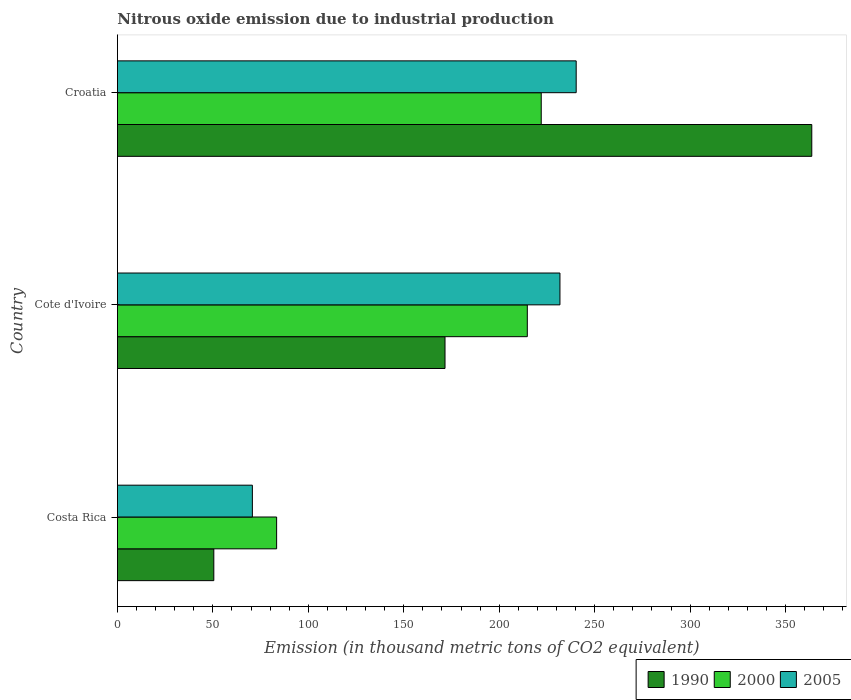How many different coloured bars are there?
Your response must be concise. 3. How many groups of bars are there?
Offer a very short reply. 3. Are the number of bars per tick equal to the number of legend labels?
Provide a short and direct response. Yes. Are the number of bars on each tick of the Y-axis equal?
Offer a terse response. Yes. How many bars are there on the 1st tick from the top?
Provide a short and direct response. 3. What is the label of the 2nd group of bars from the top?
Your response must be concise. Cote d'Ivoire. In how many cases, is the number of bars for a given country not equal to the number of legend labels?
Offer a very short reply. 0. What is the amount of nitrous oxide emitted in 2000 in Croatia?
Give a very brief answer. 222. Across all countries, what is the maximum amount of nitrous oxide emitted in 2000?
Give a very brief answer. 222. Across all countries, what is the minimum amount of nitrous oxide emitted in 2000?
Your answer should be compact. 83.4. In which country was the amount of nitrous oxide emitted in 2005 maximum?
Your response must be concise. Croatia. In which country was the amount of nitrous oxide emitted in 2000 minimum?
Offer a terse response. Costa Rica. What is the total amount of nitrous oxide emitted in 2000 in the graph?
Offer a very short reply. 520.1. What is the difference between the amount of nitrous oxide emitted in 1990 in Costa Rica and that in Croatia?
Give a very brief answer. -313.2. What is the difference between the amount of nitrous oxide emitted in 1990 in Cote d'Ivoire and the amount of nitrous oxide emitted in 2000 in Costa Rica?
Your answer should be compact. 88.2. What is the average amount of nitrous oxide emitted in 2005 per country?
Offer a very short reply. 180.93. What is the difference between the amount of nitrous oxide emitted in 2005 and amount of nitrous oxide emitted in 1990 in Costa Rica?
Your response must be concise. 20.2. In how many countries, is the amount of nitrous oxide emitted in 1990 greater than 330 thousand metric tons?
Give a very brief answer. 1. What is the ratio of the amount of nitrous oxide emitted in 2005 in Costa Rica to that in Croatia?
Ensure brevity in your answer.  0.29. Is the amount of nitrous oxide emitted in 1990 in Costa Rica less than that in Croatia?
Offer a very short reply. Yes. Is the difference between the amount of nitrous oxide emitted in 2005 in Costa Rica and Croatia greater than the difference between the amount of nitrous oxide emitted in 1990 in Costa Rica and Croatia?
Your response must be concise. Yes. What is the difference between the highest and the lowest amount of nitrous oxide emitted in 1990?
Your answer should be compact. 313.2. Is the sum of the amount of nitrous oxide emitted in 2000 in Cote d'Ivoire and Croatia greater than the maximum amount of nitrous oxide emitted in 1990 across all countries?
Your response must be concise. Yes. What does the 3rd bar from the top in Croatia represents?
Your answer should be very brief. 1990. Are all the bars in the graph horizontal?
Provide a short and direct response. Yes. How many countries are there in the graph?
Keep it short and to the point. 3. Are the values on the major ticks of X-axis written in scientific E-notation?
Provide a short and direct response. No. Does the graph contain any zero values?
Keep it short and to the point. No. What is the title of the graph?
Make the answer very short. Nitrous oxide emission due to industrial production. What is the label or title of the X-axis?
Provide a short and direct response. Emission (in thousand metric tons of CO2 equivalent). What is the label or title of the Y-axis?
Make the answer very short. Country. What is the Emission (in thousand metric tons of CO2 equivalent) of 1990 in Costa Rica?
Make the answer very short. 50.5. What is the Emission (in thousand metric tons of CO2 equivalent) of 2000 in Costa Rica?
Offer a terse response. 83.4. What is the Emission (in thousand metric tons of CO2 equivalent) of 2005 in Costa Rica?
Offer a terse response. 70.7. What is the Emission (in thousand metric tons of CO2 equivalent) of 1990 in Cote d'Ivoire?
Provide a short and direct response. 171.6. What is the Emission (in thousand metric tons of CO2 equivalent) in 2000 in Cote d'Ivoire?
Make the answer very short. 214.7. What is the Emission (in thousand metric tons of CO2 equivalent) in 2005 in Cote d'Ivoire?
Ensure brevity in your answer.  231.8. What is the Emission (in thousand metric tons of CO2 equivalent) in 1990 in Croatia?
Offer a very short reply. 363.7. What is the Emission (in thousand metric tons of CO2 equivalent) of 2000 in Croatia?
Your answer should be very brief. 222. What is the Emission (in thousand metric tons of CO2 equivalent) of 2005 in Croatia?
Your answer should be compact. 240.3. Across all countries, what is the maximum Emission (in thousand metric tons of CO2 equivalent) of 1990?
Keep it short and to the point. 363.7. Across all countries, what is the maximum Emission (in thousand metric tons of CO2 equivalent) in 2000?
Offer a very short reply. 222. Across all countries, what is the maximum Emission (in thousand metric tons of CO2 equivalent) of 2005?
Your answer should be very brief. 240.3. Across all countries, what is the minimum Emission (in thousand metric tons of CO2 equivalent) of 1990?
Make the answer very short. 50.5. Across all countries, what is the minimum Emission (in thousand metric tons of CO2 equivalent) in 2000?
Provide a short and direct response. 83.4. Across all countries, what is the minimum Emission (in thousand metric tons of CO2 equivalent) in 2005?
Provide a short and direct response. 70.7. What is the total Emission (in thousand metric tons of CO2 equivalent) in 1990 in the graph?
Your answer should be very brief. 585.8. What is the total Emission (in thousand metric tons of CO2 equivalent) in 2000 in the graph?
Keep it short and to the point. 520.1. What is the total Emission (in thousand metric tons of CO2 equivalent) in 2005 in the graph?
Your answer should be very brief. 542.8. What is the difference between the Emission (in thousand metric tons of CO2 equivalent) in 1990 in Costa Rica and that in Cote d'Ivoire?
Your response must be concise. -121.1. What is the difference between the Emission (in thousand metric tons of CO2 equivalent) of 2000 in Costa Rica and that in Cote d'Ivoire?
Your answer should be very brief. -131.3. What is the difference between the Emission (in thousand metric tons of CO2 equivalent) of 2005 in Costa Rica and that in Cote d'Ivoire?
Offer a terse response. -161.1. What is the difference between the Emission (in thousand metric tons of CO2 equivalent) in 1990 in Costa Rica and that in Croatia?
Offer a very short reply. -313.2. What is the difference between the Emission (in thousand metric tons of CO2 equivalent) of 2000 in Costa Rica and that in Croatia?
Provide a short and direct response. -138.6. What is the difference between the Emission (in thousand metric tons of CO2 equivalent) in 2005 in Costa Rica and that in Croatia?
Offer a very short reply. -169.6. What is the difference between the Emission (in thousand metric tons of CO2 equivalent) of 1990 in Cote d'Ivoire and that in Croatia?
Make the answer very short. -192.1. What is the difference between the Emission (in thousand metric tons of CO2 equivalent) in 1990 in Costa Rica and the Emission (in thousand metric tons of CO2 equivalent) in 2000 in Cote d'Ivoire?
Your response must be concise. -164.2. What is the difference between the Emission (in thousand metric tons of CO2 equivalent) in 1990 in Costa Rica and the Emission (in thousand metric tons of CO2 equivalent) in 2005 in Cote d'Ivoire?
Your answer should be very brief. -181.3. What is the difference between the Emission (in thousand metric tons of CO2 equivalent) of 2000 in Costa Rica and the Emission (in thousand metric tons of CO2 equivalent) of 2005 in Cote d'Ivoire?
Provide a short and direct response. -148.4. What is the difference between the Emission (in thousand metric tons of CO2 equivalent) in 1990 in Costa Rica and the Emission (in thousand metric tons of CO2 equivalent) in 2000 in Croatia?
Give a very brief answer. -171.5. What is the difference between the Emission (in thousand metric tons of CO2 equivalent) of 1990 in Costa Rica and the Emission (in thousand metric tons of CO2 equivalent) of 2005 in Croatia?
Provide a short and direct response. -189.8. What is the difference between the Emission (in thousand metric tons of CO2 equivalent) of 2000 in Costa Rica and the Emission (in thousand metric tons of CO2 equivalent) of 2005 in Croatia?
Your answer should be compact. -156.9. What is the difference between the Emission (in thousand metric tons of CO2 equivalent) in 1990 in Cote d'Ivoire and the Emission (in thousand metric tons of CO2 equivalent) in 2000 in Croatia?
Provide a succinct answer. -50.4. What is the difference between the Emission (in thousand metric tons of CO2 equivalent) of 1990 in Cote d'Ivoire and the Emission (in thousand metric tons of CO2 equivalent) of 2005 in Croatia?
Give a very brief answer. -68.7. What is the difference between the Emission (in thousand metric tons of CO2 equivalent) of 2000 in Cote d'Ivoire and the Emission (in thousand metric tons of CO2 equivalent) of 2005 in Croatia?
Your response must be concise. -25.6. What is the average Emission (in thousand metric tons of CO2 equivalent) of 1990 per country?
Your response must be concise. 195.27. What is the average Emission (in thousand metric tons of CO2 equivalent) of 2000 per country?
Ensure brevity in your answer.  173.37. What is the average Emission (in thousand metric tons of CO2 equivalent) in 2005 per country?
Ensure brevity in your answer.  180.93. What is the difference between the Emission (in thousand metric tons of CO2 equivalent) of 1990 and Emission (in thousand metric tons of CO2 equivalent) of 2000 in Costa Rica?
Give a very brief answer. -32.9. What is the difference between the Emission (in thousand metric tons of CO2 equivalent) in 1990 and Emission (in thousand metric tons of CO2 equivalent) in 2005 in Costa Rica?
Your answer should be very brief. -20.2. What is the difference between the Emission (in thousand metric tons of CO2 equivalent) in 2000 and Emission (in thousand metric tons of CO2 equivalent) in 2005 in Costa Rica?
Your response must be concise. 12.7. What is the difference between the Emission (in thousand metric tons of CO2 equivalent) in 1990 and Emission (in thousand metric tons of CO2 equivalent) in 2000 in Cote d'Ivoire?
Provide a succinct answer. -43.1. What is the difference between the Emission (in thousand metric tons of CO2 equivalent) in 1990 and Emission (in thousand metric tons of CO2 equivalent) in 2005 in Cote d'Ivoire?
Provide a succinct answer. -60.2. What is the difference between the Emission (in thousand metric tons of CO2 equivalent) of 2000 and Emission (in thousand metric tons of CO2 equivalent) of 2005 in Cote d'Ivoire?
Provide a succinct answer. -17.1. What is the difference between the Emission (in thousand metric tons of CO2 equivalent) of 1990 and Emission (in thousand metric tons of CO2 equivalent) of 2000 in Croatia?
Make the answer very short. 141.7. What is the difference between the Emission (in thousand metric tons of CO2 equivalent) in 1990 and Emission (in thousand metric tons of CO2 equivalent) in 2005 in Croatia?
Provide a succinct answer. 123.4. What is the difference between the Emission (in thousand metric tons of CO2 equivalent) in 2000 and Emission (in thousand metric tons of CO2 equivalent) in 2005 in Croatia?
Make the answer very short. -18.3. What is the ratio of the Emission (in thousand metric tons of CO2 equivalent) in 1990 in Costa Rica to that in Cote d'Ivoire?
Keep it short and to the point. 0.29. What is the ratio of the Emission (in thousand metric tons of CO2 equivalent) of 2000 in Costa Rica to that in Cote d'Ivoire?
Your answer should be very brief. 0.39. What is the ratio of the Emission (in thousand metric tons of CO2 equivalent) in 2005 in Costa Rica to that in Cote d'Ivoire?
Keep it short and to the point. 0.3. What is the ratio of the Emission (in thousand metric tons of CO2 equivalent) in 1990 in Costa Rica to that in Croatia?
Offer a very short reply. 0.14. What is the ratio of the Emission (in thousand metric tons of CO2 equivalent) in 2000 in Costa Rica to that in Croatia?
Your answer should be very brief. 0.38. What is the ratio of the Emission (in thousand metric tons of CO2 equivalent) of 2005 in Costa Rica to that in Croatia?
Provide a succinct answer. 0.29. What is the ratio of the Emission (in thousand metric tons of CO2 equivalent) in 1990 in Cote d'Ivoire to that in Croatia?
Make the answer very short. 0.47. What is the ratio of the Emission (in thousand metric tons of CO2 equivalent) of 2000 in Cote d'Ivoire to that in Croatia?
Keep it short and to the point. 0.97. What is the ratio of the Emission (in thousand metric tons of CO2 equivalent) in 2005 in Cote d'Ivoire to that in Croatia?
Provide a short and direct response. 0.96. What is the difference between the highest and the second highest Emission (in thousand metric tons of CO2 equivalent) of 1990?
Give a very brief answer. 192.1. What is the difference between the highest and the second highest Emission (in thousand metric tons of CO2 equivalent) of 2005?
Your response must be concise. 8.5. What is the difference between the highest and the lowest Emission (in thousand metric tons of CO2 equivalent) in 1990?
Keep it short and to the point. 313.2. What is the difference between the highest and the lowest Emission (in thousand metric tons of CO2 equivalent) of 2000?
Your answer should be compact. 138.6. What is the difference between the highest and the lowest Emission (in thousand metric tons of CO2 equivalent) of 2005?
Make the answer very short. 169.6. 